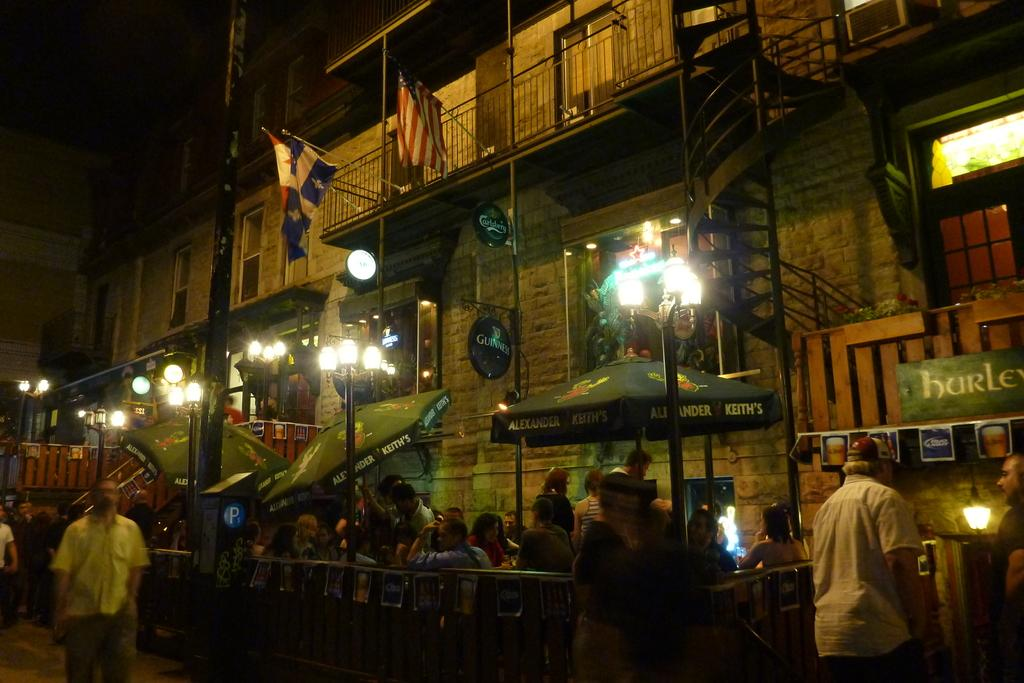What type of structure is visible in the image? There is a building in the image. What can be seen on poles in the image? There are lights on poles in the image. What are the umbrellas in the image used for? The umbrellas in the image have text on them, which suggests they might be used for advertising or branding. What are the people in the image doing? There are people sitting and walking in the image. What decorative elements can be seen in the image? There are flags in the image. What type of jelly can be seen on the chin of the person in the image? There is no jelly visible on anyone's chin in the image. Where is the cemetery located in the image? There is no cemetery present in the image. 